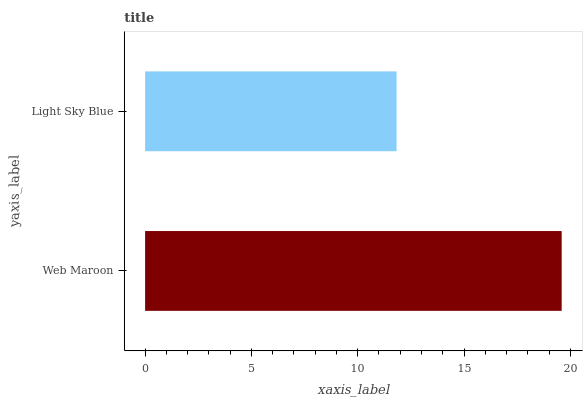Is Light Sky Blue the minimum?
Answer yes or no. Yes. Is Web Maroon the maximum?
Answer yes or no. Yes. Is Light Sky Blue the maximum?
Answer yes or no. No. Is Web Maroon greater than Light Sky Blue?
Answer yes or no. Yes. Is Light Sky Blue less than Web Maroon?
Answer yes or no. Yes. Is Light Sky Blue greater than Web Maroon?
Answer yes or no. No. Is Web Maroon less than Light Sky Blue?
Answer yes or no. No. Is Web Maroon the high median?
Answer yes or no. Yes. Is Light Sky Blue the low median?
Answer yes or no. Yes. Is Light Sky Blue the high median?
Answer yes or no. No. Is Web Maroon the low median?
Answer yes or no. No. 